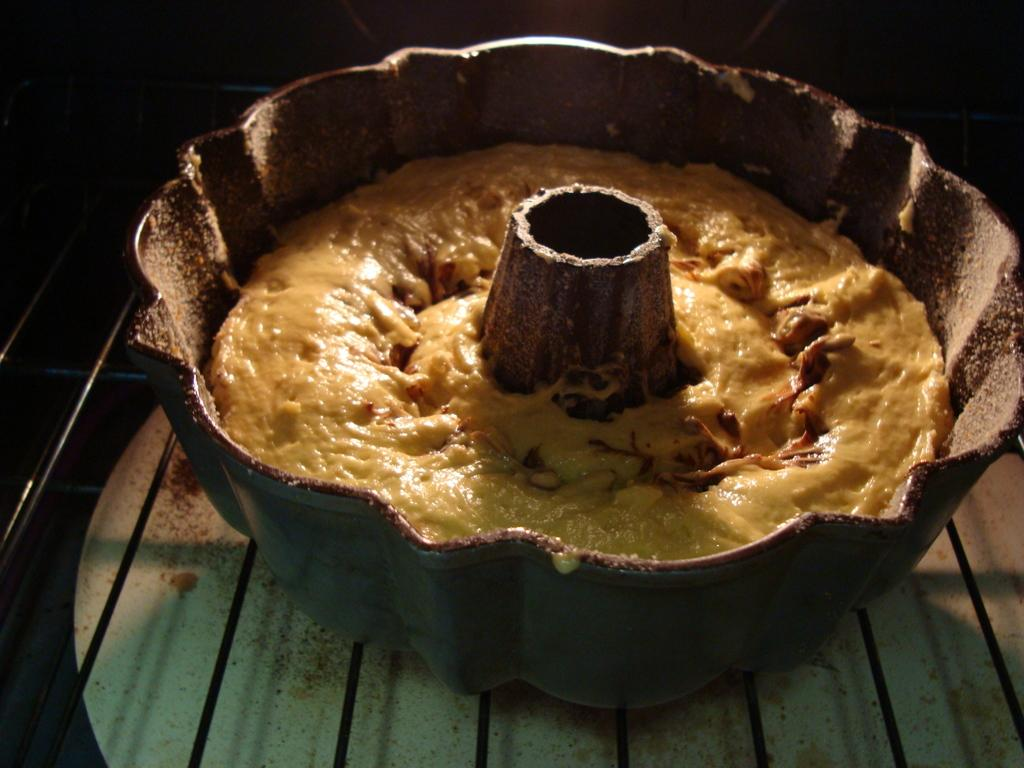What is the main subject of the image? The main subject of the image is a cake. What object is associated with the cake in the image? There is a cake tin in the image. What other item can be seen in the image? There is a grill in the image. Can you see any dinosaurs roaming around the cake in the image? No, there are no dinosaurs present in the image. Is the cake being blown out in the image? There is no indication of a cake being blown out in the image. 